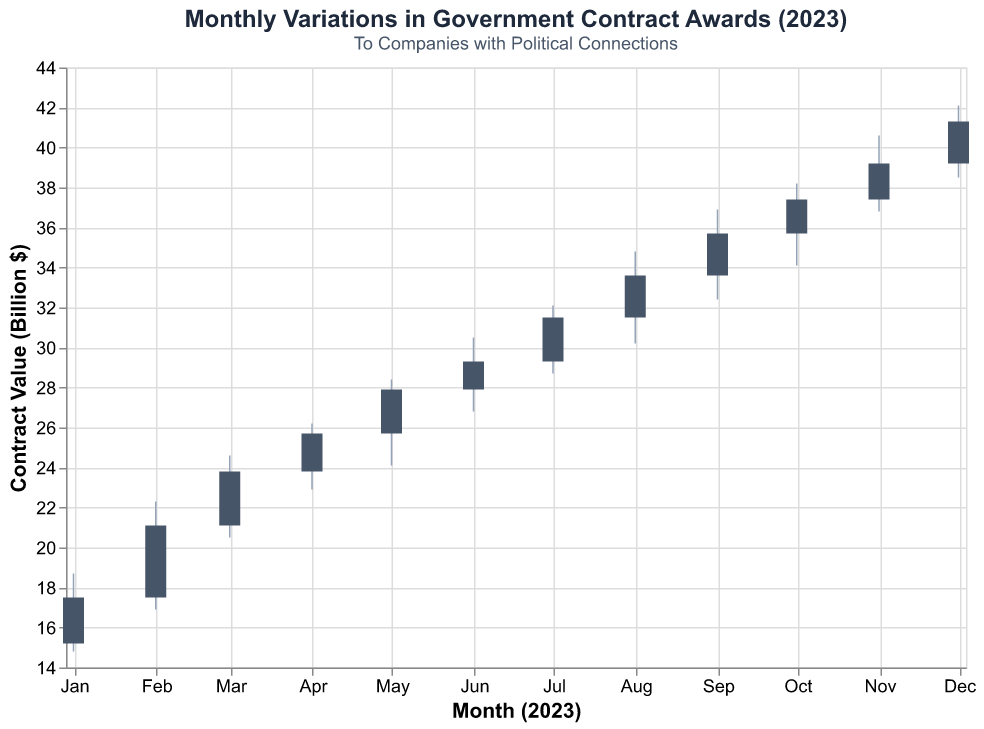What is the title of the figure? The title of a figure is typically located at or near the top of the visualization and summarises the content of the chart. The title here is "Monthly Variations in Government Contract Awards (2023)"
Answer: Monthly Variations in Government Contract Awards (2023) What does the color of the bars represent? The color of the bars in the chart represents the contract value in billions of dollars for each month.
Answer: Contract value in billions $ Which company received the highest contract value in February 2023? To determine which company received the highest contract value in February, look at February's bar and check the company name associated with this period.
Answer: Lockheed Martin How much did contract values increase from January 2023 to December 2023? To find this, subtract the close value of January (17.5) from the close value of December (41.3). Both values can be obtained from observing the endpoints of the bars in January and December. Calculation: 41.3 - 17.5 = 23.8
Answer: 23.8 billion $ What is the average closing contract value for the year 2023? Sum all the closing values from January to December and then divide by the number of months (12). (17.5 + 21.1 + 23.8 + 25.7 + 27.9 + 29.3 + 31.5 + 33.6 + 35.7 + 37.4 + 39.2 + 41.3) / 12
Answer: 29.66 billion $ Which month saw the highest volatility in contract values? Volatility can be indicated by the largest difference between the high and low values in a given month. Compare the differences (High - Low) for each month and identify the largest. August: (34.8 - 30.2 = 4.6) has the highest swing.
Answer: August How many companies are involved in this dataset? Count the number of unique company names listed in the dataset. There are 12, one for each month.
Answer: 12 From which month to which month did the contract values see a steady climb every month? Observe the closing values month by month and identify the period where each subsequent month has a higher closing value than the previous month. From January (17.5) to December (41.3) witnessed a steady increase.
Answer: January to December In which month did the contract value not fall below 30 billion dollars? This requires checking the "Low" value for each month and finding months where the low point was above 30 billion. Only August to December have lows above 30 billion.
Answer: August to December Which month had the smallest increase from opening to closing contract value? To find this, for each month, compute (Close - Open) and identify the smallest value. March has the smallest increase of (23.8 - 21.1 = 2.7).
Answer: March 